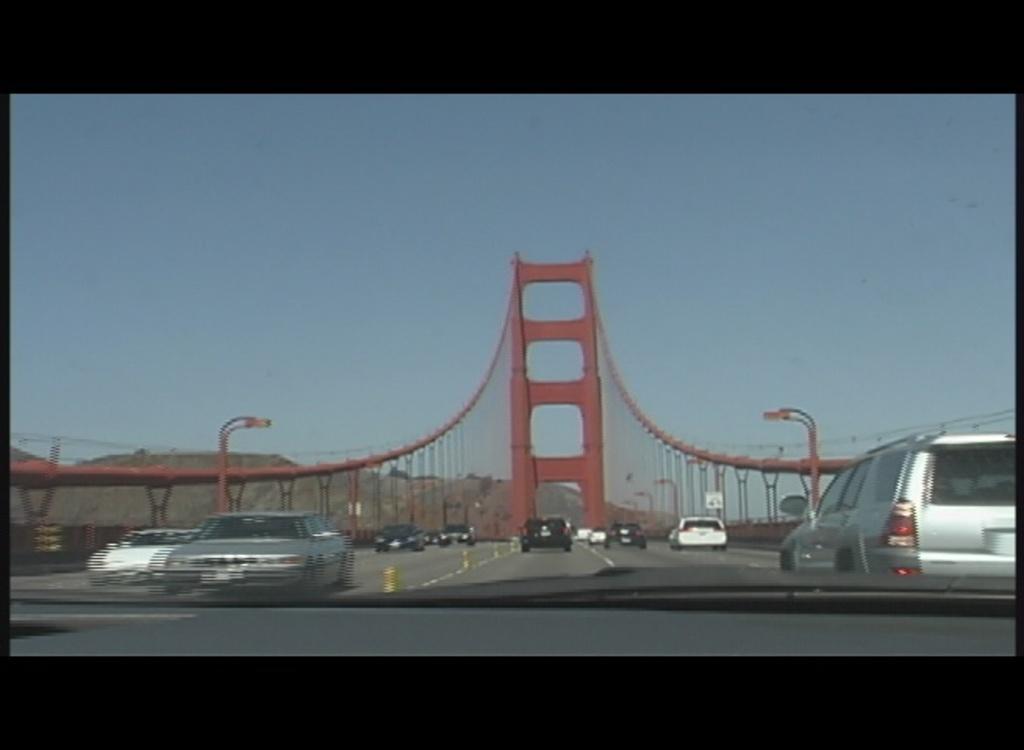How would you summarize this image in a sentence or two? In this image we can see the photo which is taken from the vehicle and we can see some vehicles on the road and there is a bridge in the background and we can see the mountains. There are few street lights and at the top we can see the sky. 